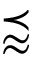<formula> <loc_0><loc_0><loc_500><loc_500>\prec a p p r o x</formula> 